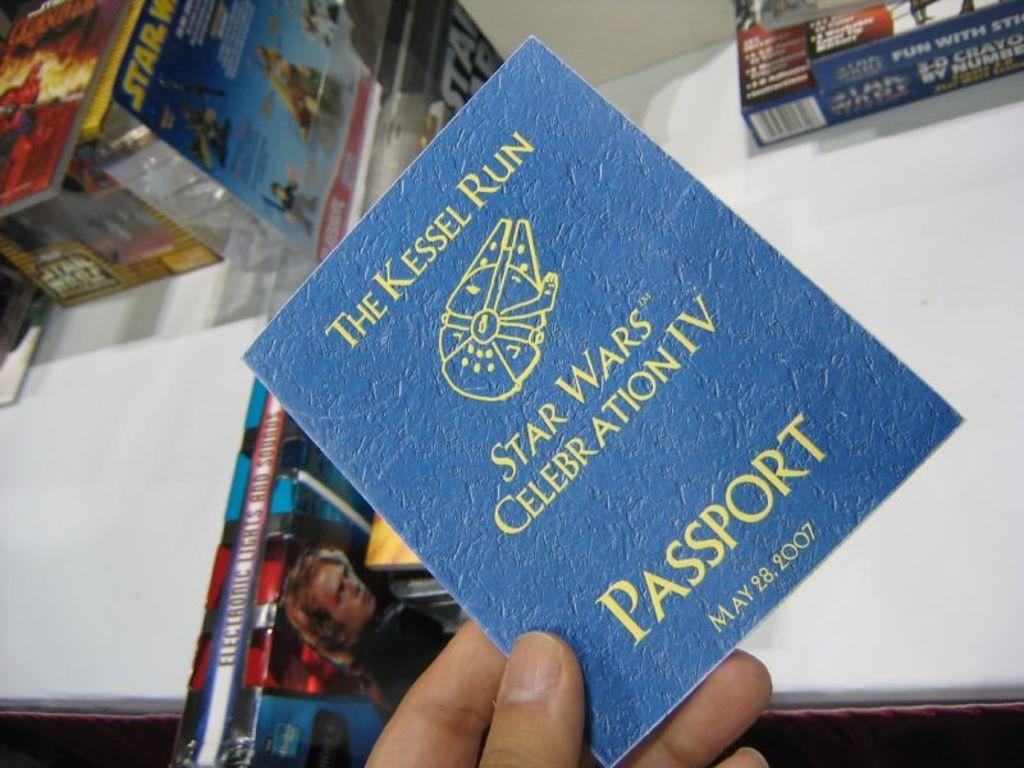What movie franchise is the theme of this passport?
Your response must be concise. Star wars. What is the date on this?
Offer a very short reply. May 28, 2007. 